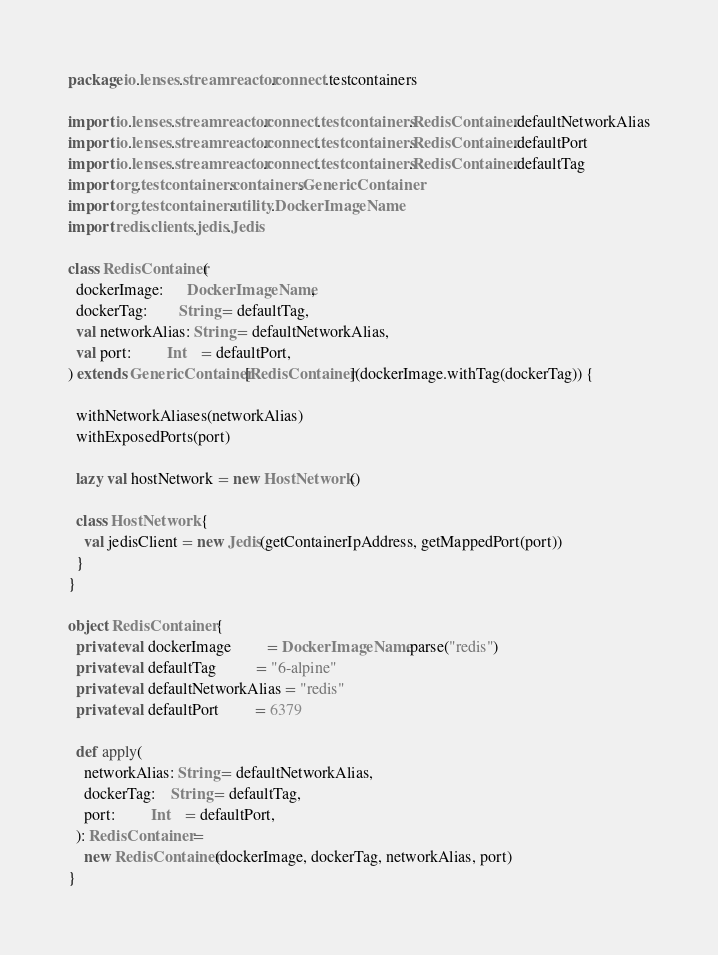<code> <loc_0><loc_0><loc_500><loc_500><_Scala_>package io.lenses.streamreactor.connect.testcontainers

import io.lenses.streamreactor.connect.testcontainers.RedisContainer.defaultNetworkAlias
import io.lenses.streamreactor.connect.testcontainers.RedisContainer.defaultPort
import io.lenses.streamreactor.connect.testcontainers.RedisContainer.defaultTag
import org.testcontainers.containers.GenericContainer
import org.testcontainers.utility.DockerImageName
import redis.clients.jedis.Jedis

class RedisContainer(
  dockerImage:      DockerImageName,
  dockerTag:        String = defaultTag,
  val networkAlias: String = defaultNetworkAlias,
  val port:         Int    = defaultPort,
) extends GenericContainer[RedisContainer](dockerImage.withTag(dockerTag)) {

  withNetworkAliases(networkAlias)
  withExposedPorts(port)

  lazy val hostNetwork = new HostNetwork()

  class HostNetwork {
    val jedisClient = new Jedis(getContainerIpAddress, getMappedPort(port))
  }
}

object RedisContainer {
  private val dockerImage         = DockerImageName.parse("redis")
  private val defaultTag          = "6-alpine"
  private val defaultNetworkAlias = "redis"
  private val defaultPort         = 6379

  def apply(
    networkAlias: String = defaultNetworkAlias,
    dockerTag:    String = defaultTag,
    port:         Int    = defaultPort,
  ): RedisContainer =
    new RedisContainer(dockerImage, dockerTag, networkAlias, port)
}
</code> 